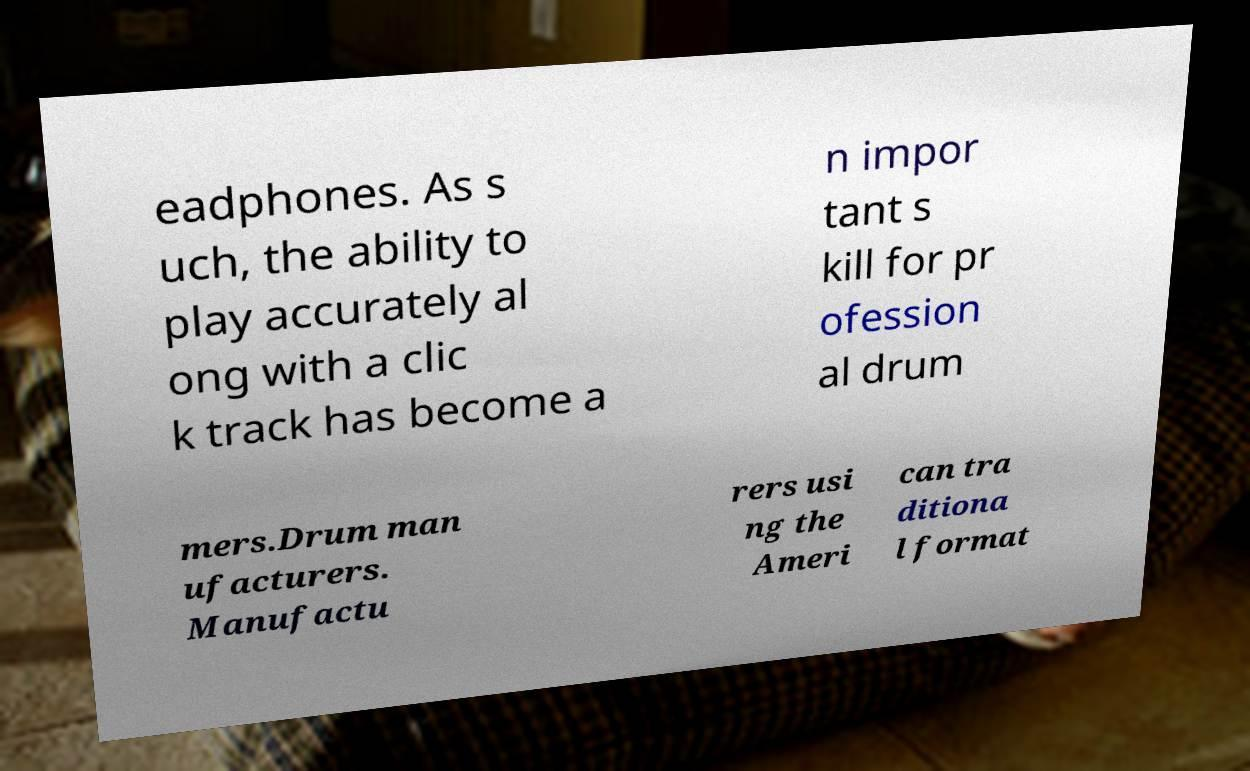Could you assist in decoding the text presented in this image and type it out clearly? eadphones. As s uch, the ability to play accurately al ong with a clic k track has become a n impor tant s kill for pr ofession al drum mers.Drum man ufacturers. Manufactu rers usi ng the Ameri can tra ditiona l format 